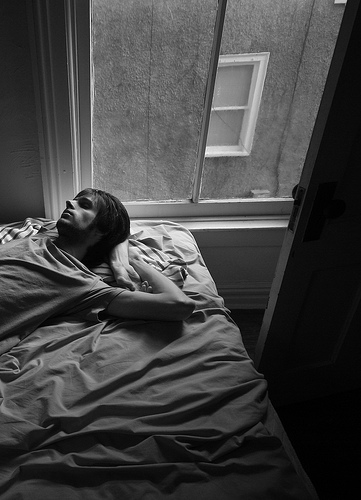The person that is lying is lying where? The person is lying in the bed. 